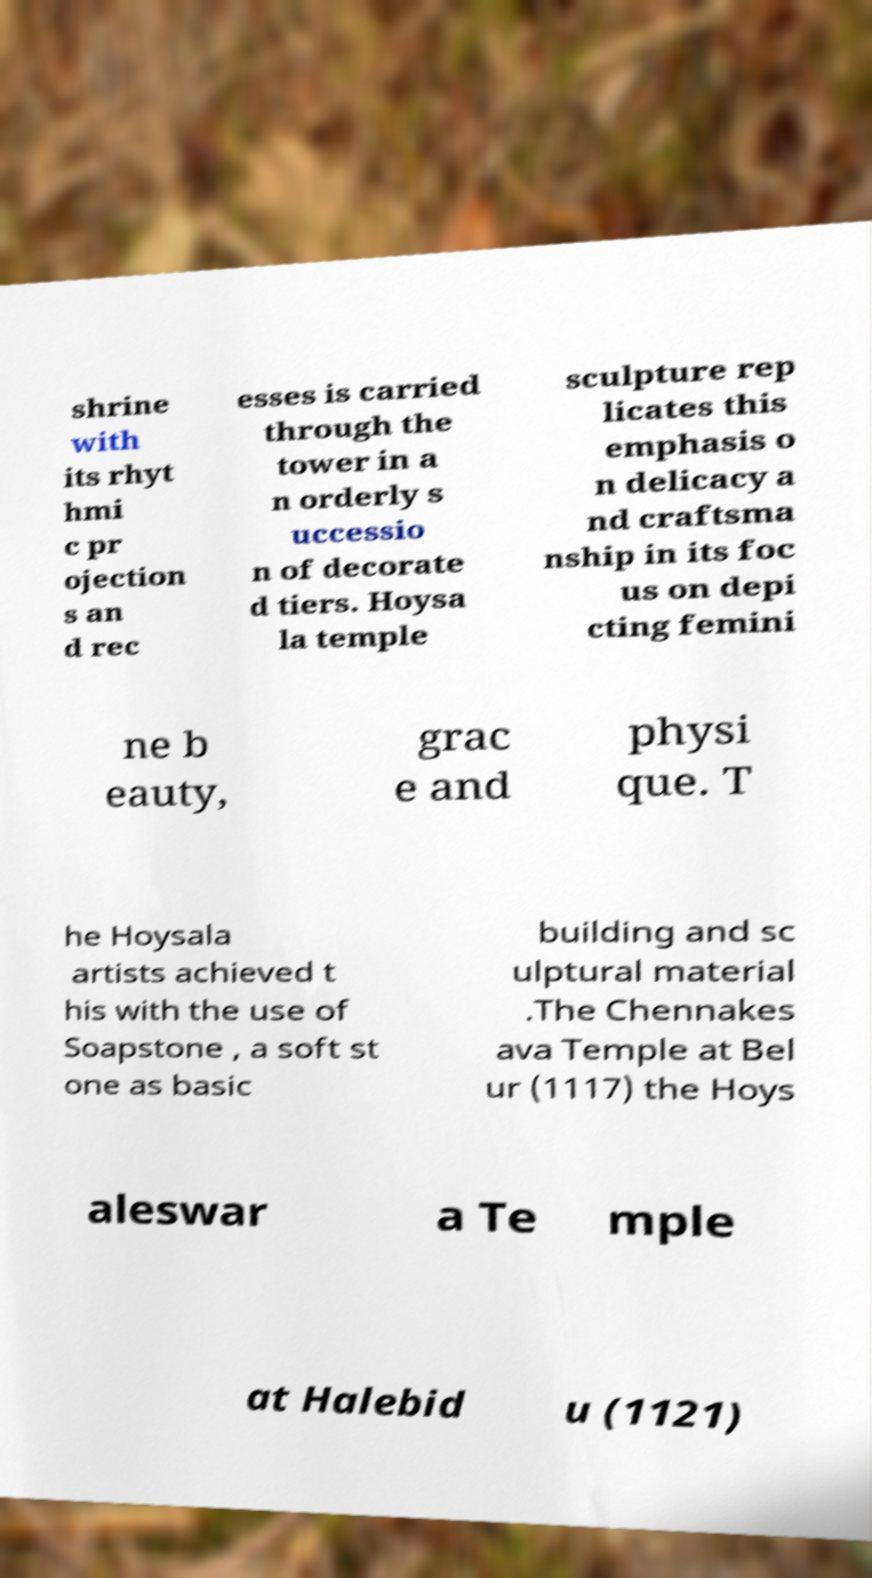For documentation purposes, I need the text within this image transcribed. Could you provide that? shrine with its rhyt hmi c pr ojection s an d rec esses is carried through the tower in a n orderly s uccessio n of decorate d tiers. Hoysa la temple sculpture rep licates this emphasis o n delicacy a nd craftsma nship in its foc us on depi cting femini ne b eauty, grac e and physi que. T he Hoysala artists achieved t his with the use of Soapstone , a soft st one as basic building and sc ulptural material .The Chennakes ava Temple at Bel ur (1117) the Hoys aleswar a Te mple at Halebid u (1121) 